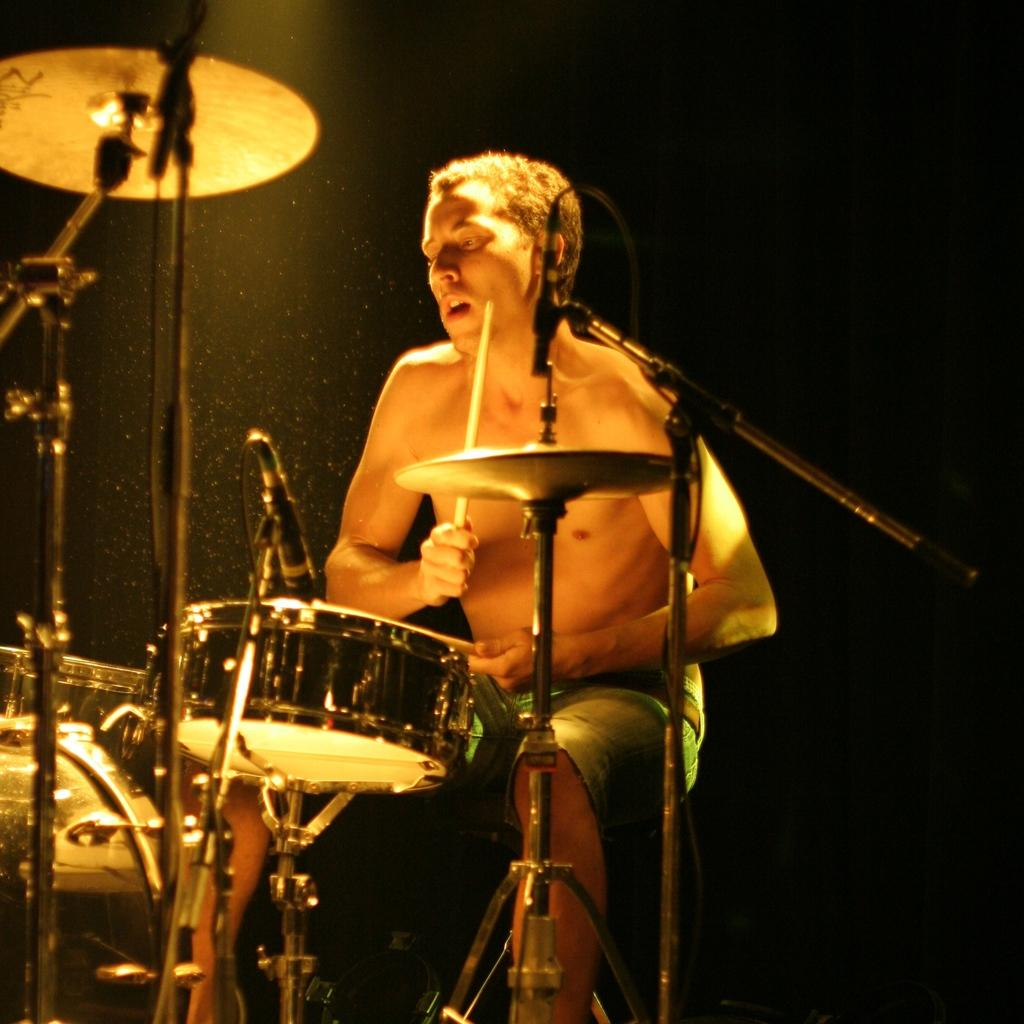What is the main subject of the image? There is a man in the image. What is the man holding in his hands? The man is holding sticks in his hands. What musical instrument can be seen in the image? There is a drum set in the image. What type of can is visible on the drum set in the image? There is no can visible on the drum set in the image. How many women are present in the image? There is no mention of women in the provided facts, so we cannot determine their presence in the image. 